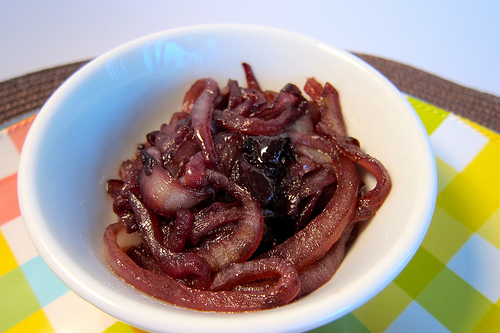<image>
Is the onion under the bowl? No. The onion is not positioned under the bowl. The vertical relationship between these objects is different. Is the food in the cup? Yes. The food is contained within or inside the cup, showing a containment relationship. 